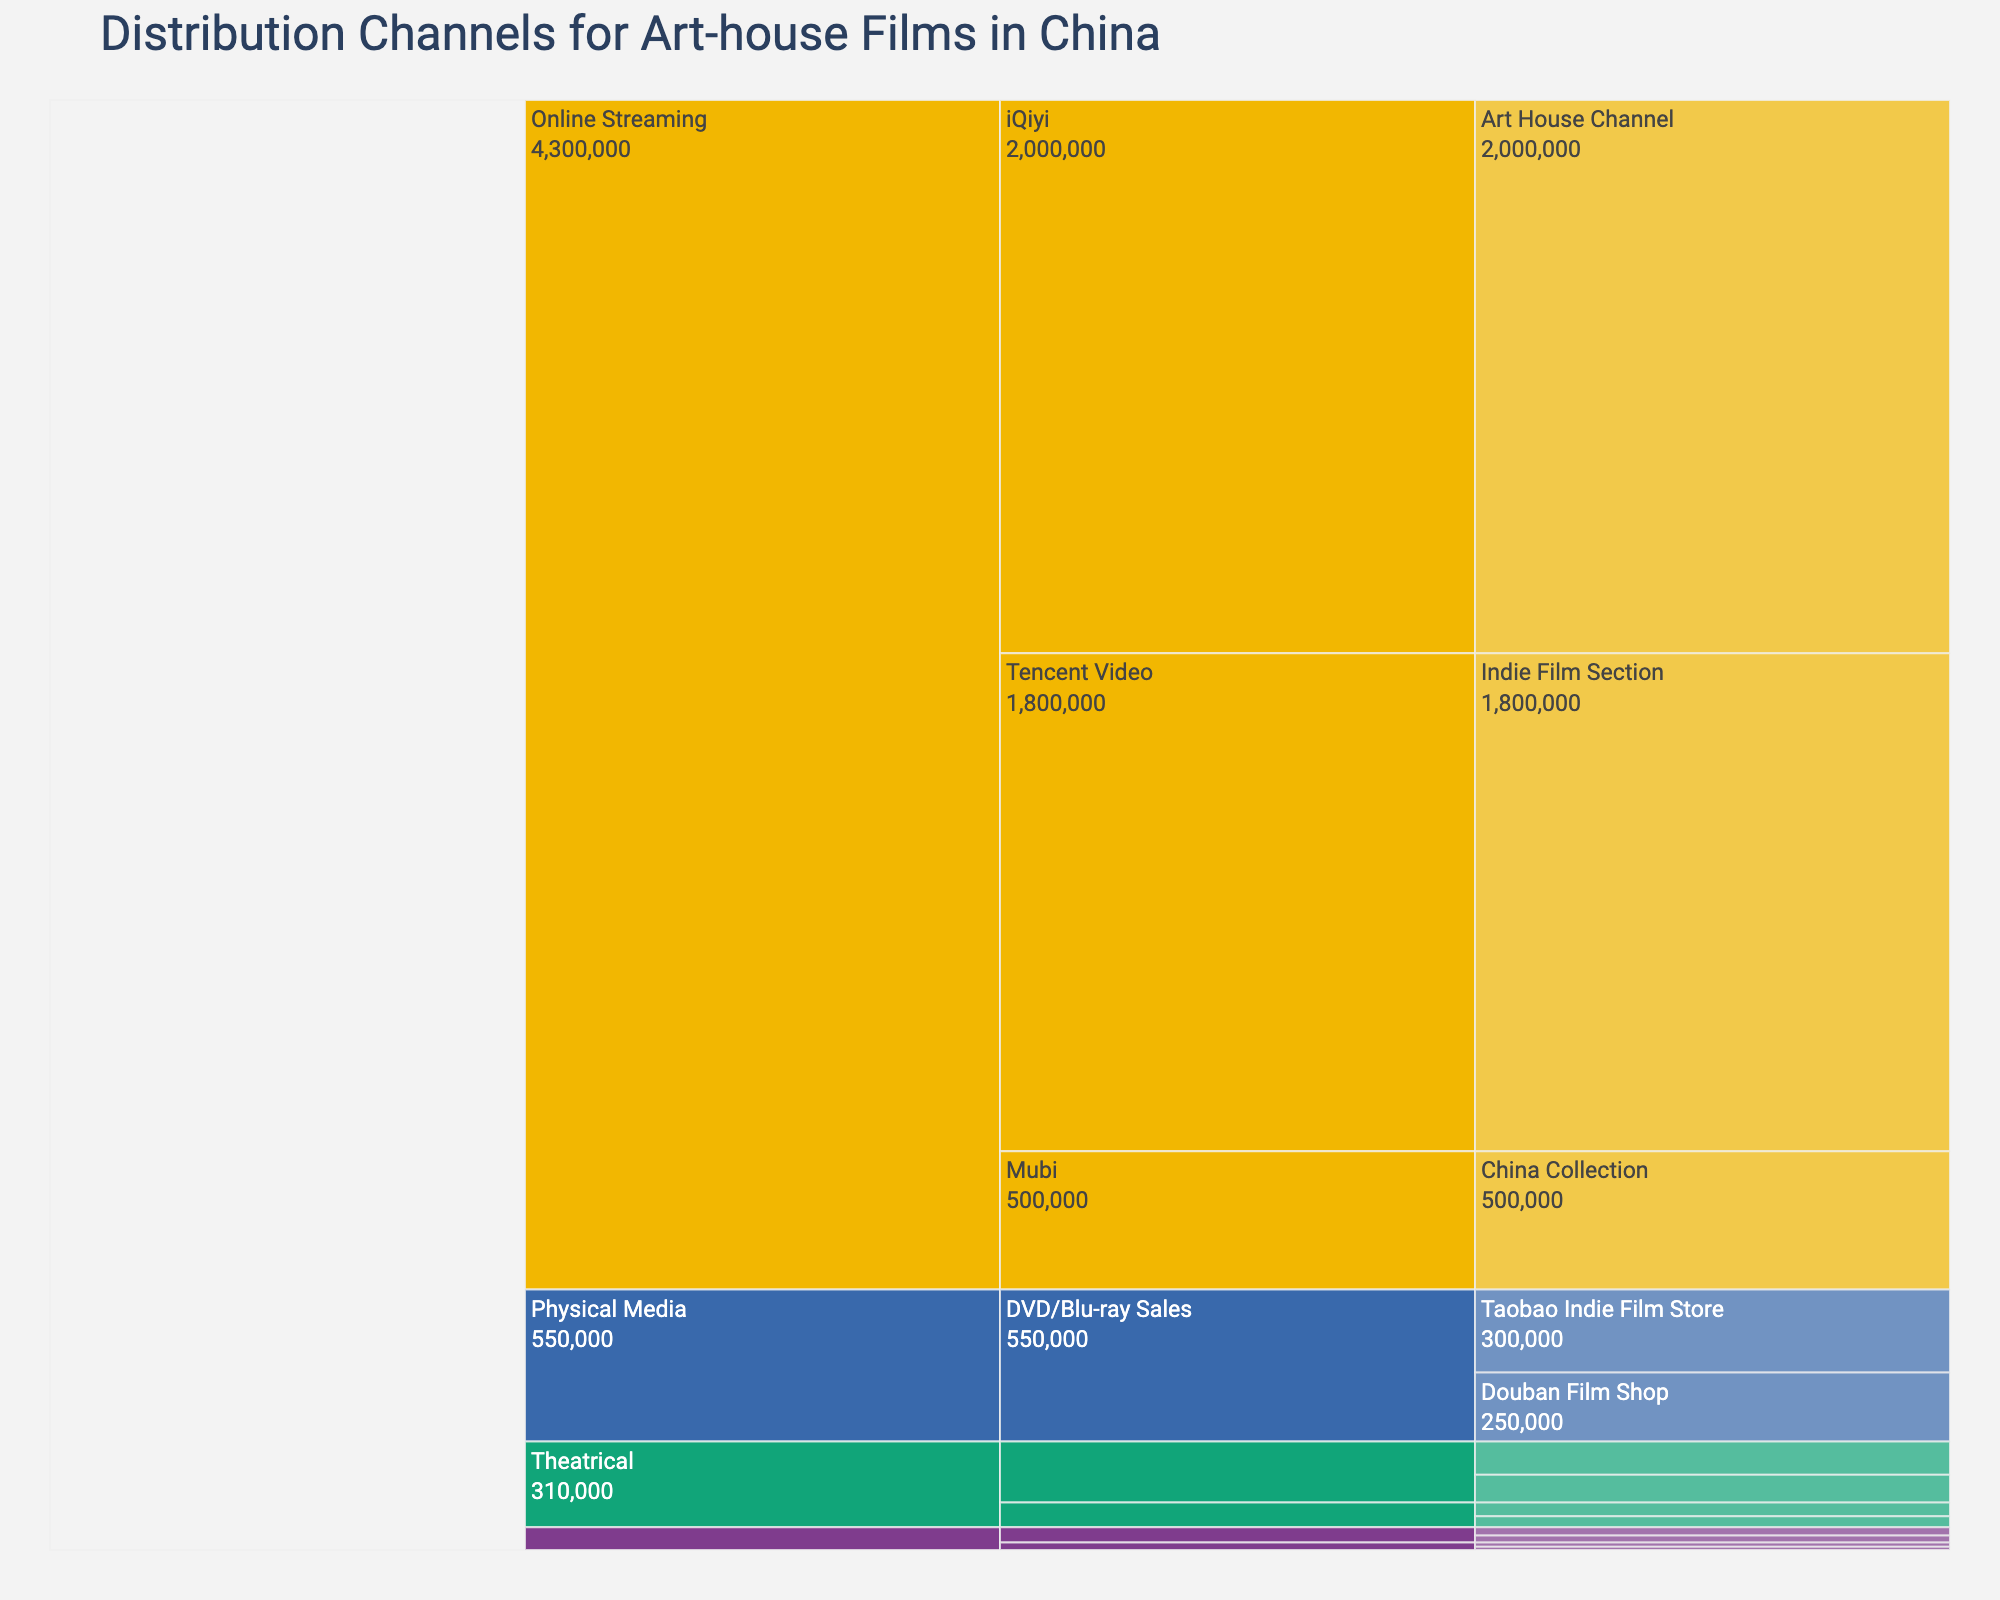What is the title of the chart? The title of the chart is usually displayed prominently at the top and it summarizes the content of the figure. In this case, based on the code provided, the title given is "Distribution Channels for Art-house Films in China".
Answer: Distribution Channels for Art-house Films in China Which platform has the highest audience reach? To find the answer, identify the block that represents the platforms. Look at the summary data for each platform, and find which one has the highest value. According to the data, 'Online Streaming' has the highest individual blocks of audience reach.
Answer: Online Streaming What is the combined audience reach of the two film festivals listed under the Theatrical platform? Look at the blocks representing the film festivals under the 'Theatrical' platform. Sum up the audience reach of "Beijing International Film Festival" and "Shanghai International Film Festival" (100,000 and 120,000 respectively). The total would be 100,000 + 120,000.
Answer: 220,000 Which sub-channel in Online Streaming has the smallest audience reach? Navigate through the blocks under 'Online Streaming' and identify the sub-channels. Compare the audience reach numbers and find the smallest one. According to the data, 'Mubi - China Collection' has the smallest audience reach.
Answer: Mubi - China Collection How does the audience reach of University Screenings compare to Art Galleries under Alternative Venues? Look at the blocks under 'Alternative Venues' and compare the values of University Screenings and Art Galleries. 'University Screenings' have 30,000 + 25,000, and 'Art Galleries' have 15,000 + 12,000. Compare these sums. 55,000 for University Screenings vs 27,000 for Art Galleries.
Answer: University Screenings have a larger audience reach than Art Galleries What is the total audience reach for Physical Media? To find the total audience reach for Physical Media, add up the numbers for DVD/Blu-ray sales (Taobao Indie Film Store and Douban Film Shop). 300,000 + 250,000.
Answer: 550,000 What is the difference in audience reach between iQiyi and Tencent Video under Online Streaming? Look at the audience reach values for iQiyi and Tencent Video under Online Streaming: 2,000,000 for iQiyi and 1,800,000 for Tencent Video. Subtract the smaller number from the larger number to find the difference.
Answer: 200,000 Under Theatrical distribution, which sub-channel has the highest audience reach? Identify the sub-channels under 'Theatrical' and compare their audience reach values. The sub-channel 'Shanghai International Film Festival' has the highest reach with 120,000.
Answer: Shanghai International Film Festival 